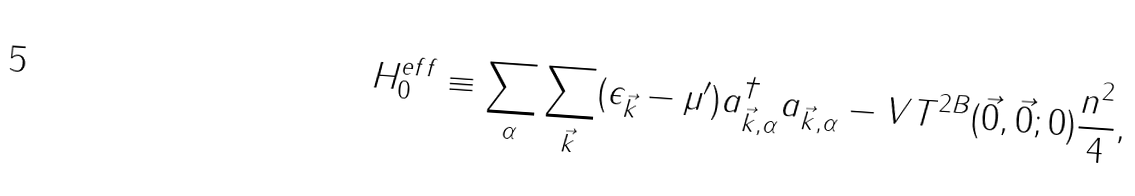<formula> <loc_0><loc_0><loc_500><loc_500>H _ { 0 } ^ { e f f } \equiv \sum _ { \alpha } \sum _ { \vec { k } } ( \epsilon _ { \vec { k } } - \mu ^ { \prime } ) a ^ { \dagger } _ { \vec { k } , \alpha } a _ { \vec { k } , \alpha } - V T ^ { 2 B } ( \vec { 0 } , \vec { 0 } ; 0 ) \frac { n ^ { 2 } } { 4 } ,</formula> 